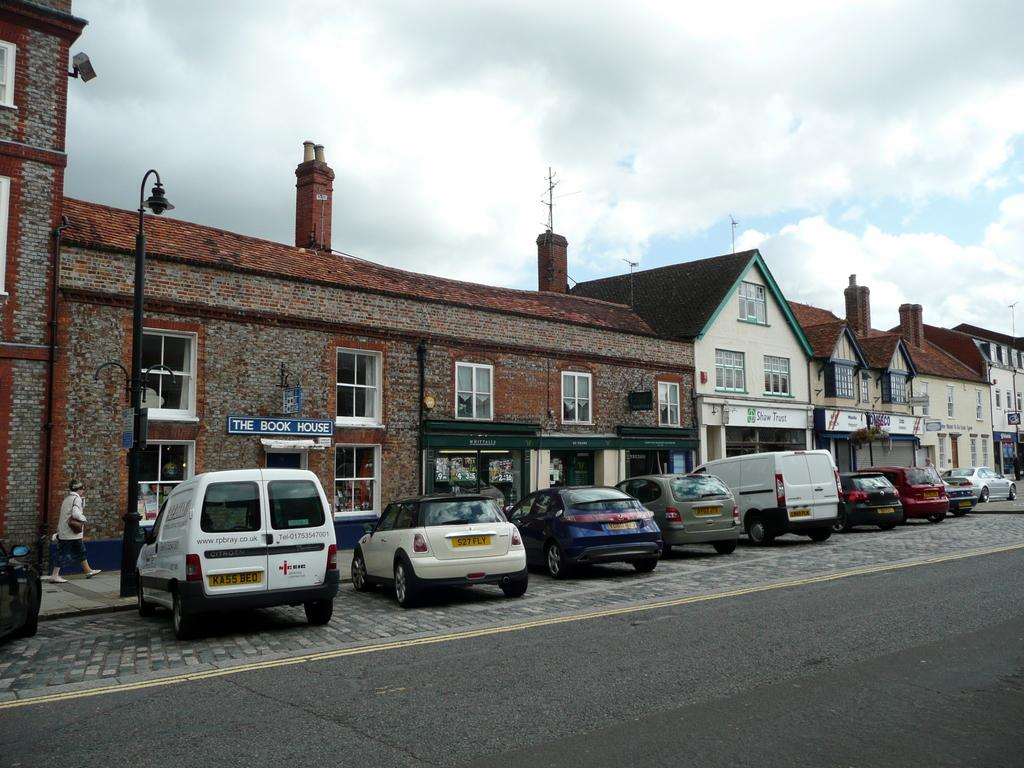What is the main feature of the image? There is a road in the image. What else can be seen on the road? There are vehicles on a platform in the image. What type of structures are present in the image? There are buildings with windows in the image. What is the purpose of the pole in the image? The purpose of the pole is not specified, but it could be for signage or other utilities. What is the person in the image doing? There is a person walking on a footpath in the image. What can be seen in the background of the image? The sky with clouds is visible in the background of the image. How many rings can be seen on the person's fingers in the image? There are no rings visible on the person's fingers in the image. What type of error can be seen in the image? There is no error present in the image. 